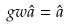<formula> <loc_0><loc_0><loc_500><loc_500>\ g w { \hat { a } } = { \hat { a } }</formula> 